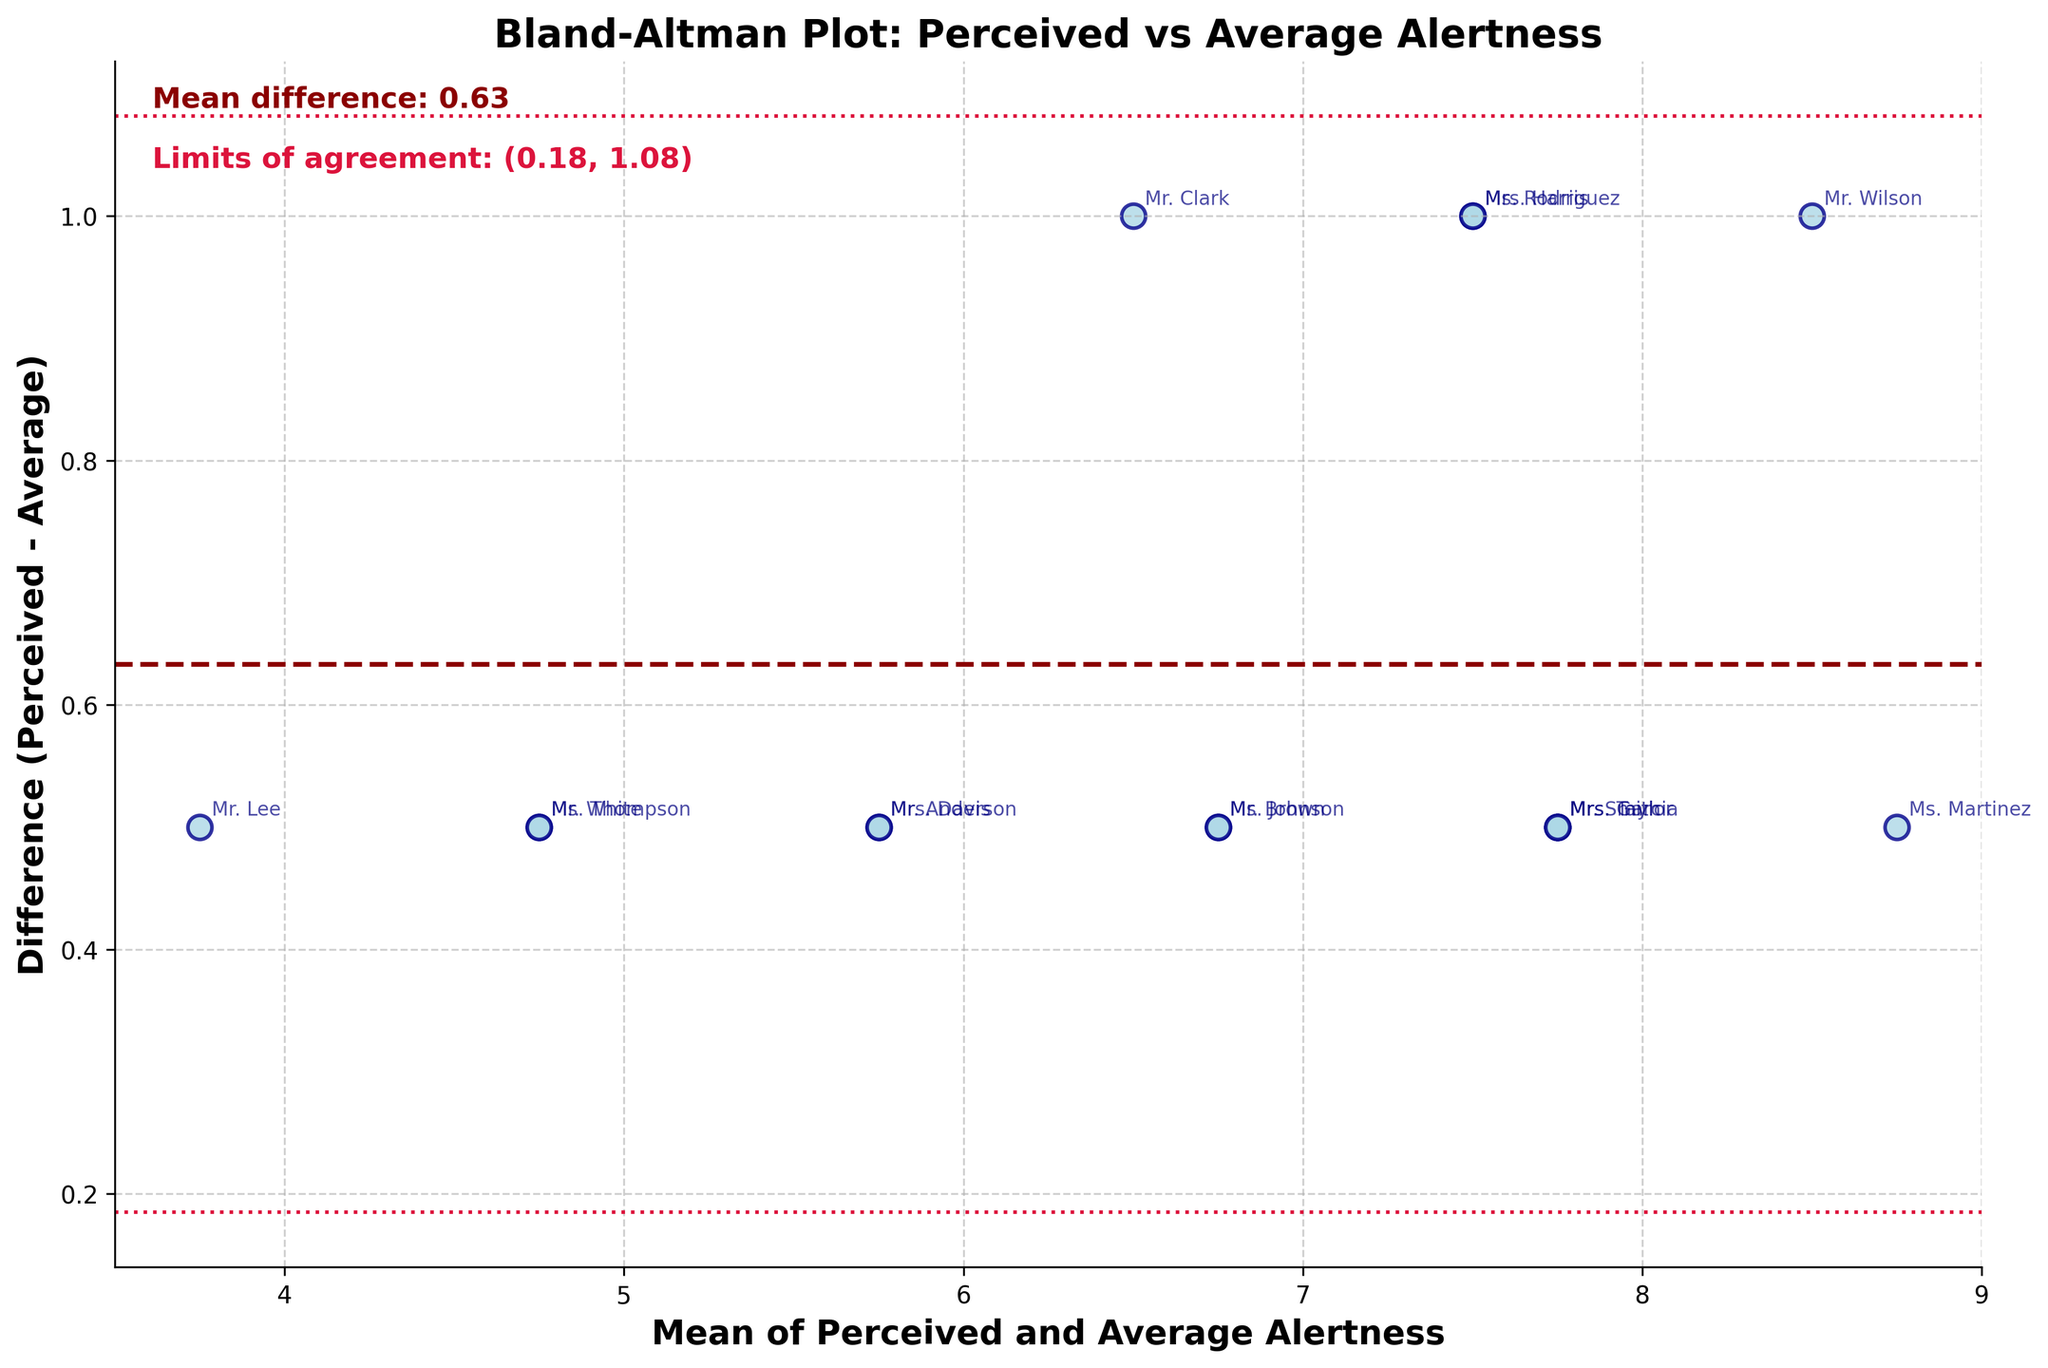What is the title of the figure? The title of the figure is located at the top and it describes what the figure is about. The title reads "Bland-Altman Plot: Perceived vs Average Alertness".
Answer: Bland-Altman Plot: Perceived vs Average Alertness How many data points are represented in the plot? Each data point corresponds to a teacher's perceived and average alertness. By counting all the scattered points on the plot, we find there are 15 data points.
Answer: 15 What do the horizontal dashed lines in the plot represent? There are three horizontal dashed lines: one in dark red and two in crimson. The dark red line represents the mean difference, and the two crimson lines depict the limits of agreement, which are ±1.96 standard deviations from the mean difference.
Answer: Mean difference and limits of agreement What is the mean difference shown in the plot? The mean difference is visually indicated by the dark red dashed line, and its value is displayed on the plot. By reading the text on the plot, it shows "Mean difference: 1.40".
Answer: 1.40 Which teacher has the largest positive difference between perceived and average alertness? By identifying the highest positive scatter point on the plot and checking the annotation, Ms. Martinez has the largest positive difference. This means her perceived alertness is much higher than her average alertness.
Answer: Ms. Martinez What range is covered by the limits of agreement? The limits of agreement are represented by the two crimson lines. The text on the plot shows this range as "Limits of agreement: (-0.03, 2.83)".
Answer: (-0.03, 2.83) How many data points fall outside the limits of agreement? To find this, we need to count the number of scatter points that lie above the upper crimson line and below the lower crimson line. There are no data points outside these lines, indicating all points fall within the limits of agreement.
Answer: 0 What does it mean if a data point is outside the limits of agreement? A data point outside the limits of agreement (±1.96 standard deviations from the mean difference) would indicate a significant discrepancy between perceived and average alertness for that teacher. It suggests the difference is not in regular bounds and might be an outlier.
Answer: Significant discrepancy Are there more teachers with positive or negative differences between perceived and average alertness? Positive differences are those above the mean difference line, while negative differences are those below it. By counting, there are more positive differences since most points are above the dark red line.
Answer: Positive For Mr. Lee, what is his perceived alertness minus average alertness? Look for Mr. Lee's annotation on the plot and find the corresponding point. His point lies at (-0.5, 0.5) where -0.5 is the mean of his alertness values and 0.5 is the difference. This indicates his perceived alertness is 0.5 higher than his average alertness.
Answer: 0.5 